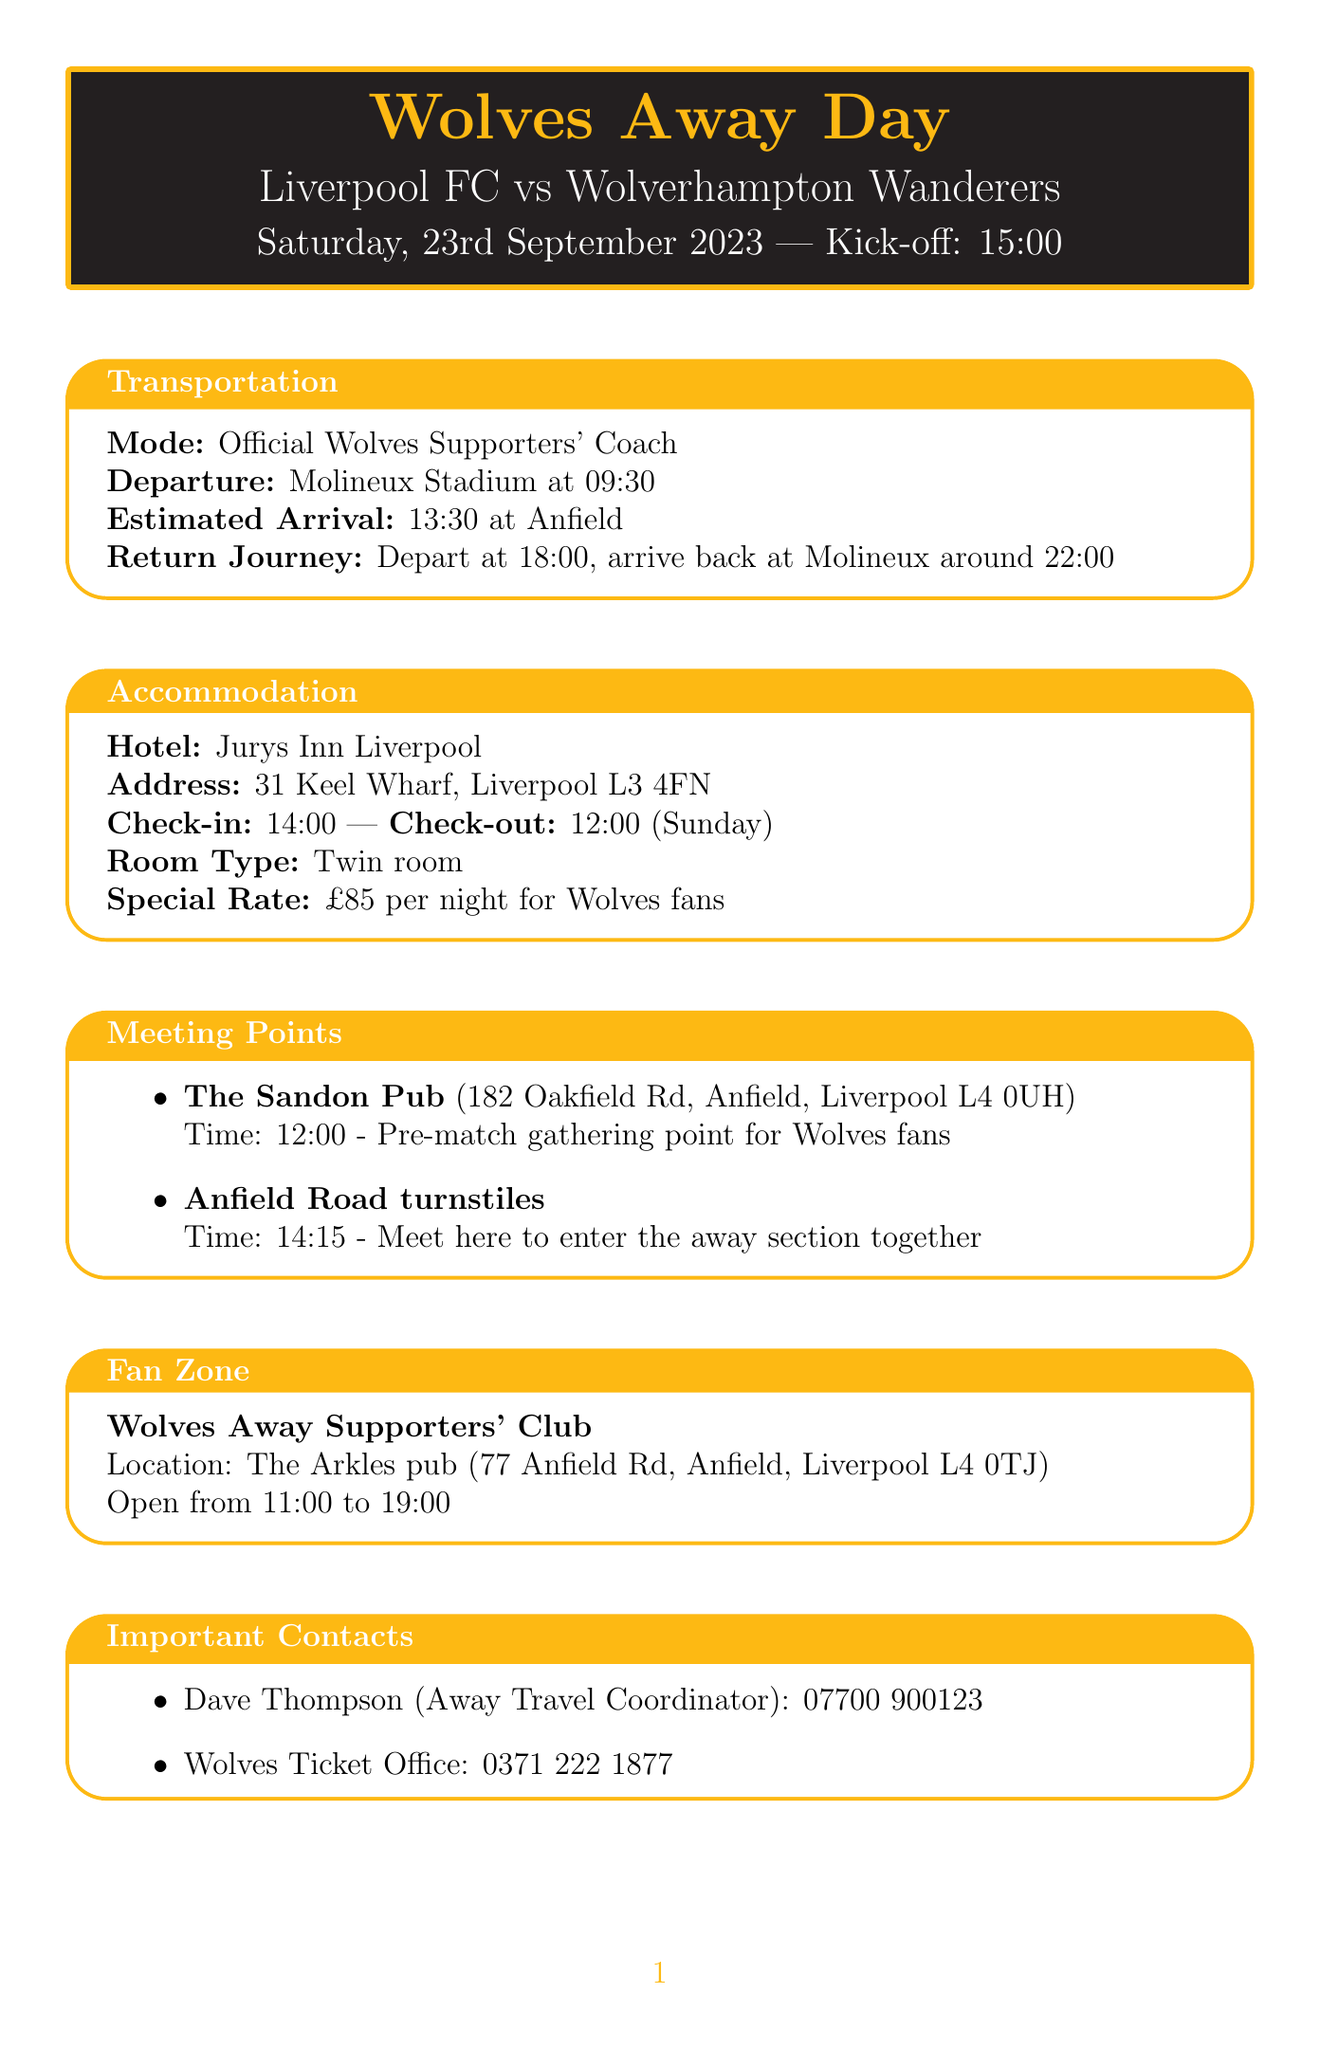What is the opponent for the match? The opponent for the match is specified in the document under "match_details".
Answer: Liverpool FC When does the coach depart from Molineux Stadium? The departure time for the coach is mentioned in the "transportation" section of the document.
Answer: 09:30 What time do fans meet at The Sandon Pub? The meeting time for the gathering point at The Sandon Pub is listed in the "meeting points" section.
Answer: 12:00 What hotel is recommended for accommodation? The hotel name is provided in the "accommodation" section of the document.
Answer: Jurys Inn Liverpool How much is the special rate for Wolves fans at the hotel? The special rate for Wolves fans is mentioned in the "accommodation" section of the document.
Answer: £85 per night What is the collection time for match tickets? The collection time for match tickets is provided in the "match tickets" section.
Answer: From 13:00 on match day Where is the Wolves Away Supporters' Club located? The location of the Wolves Away Supporters' Club can be found in the "fan zone" section of the document.
Answer: The Arkles pub Who is the Away Travel Coordinator? The name of the Away Travel Coordinator is included in the "important contacts" section of the document.
Answer: Dave Thompson What should fans remember to bring? The document includes a list of additional information that specifies what fans need to remember.
Answer: Wolves Away Membership card 